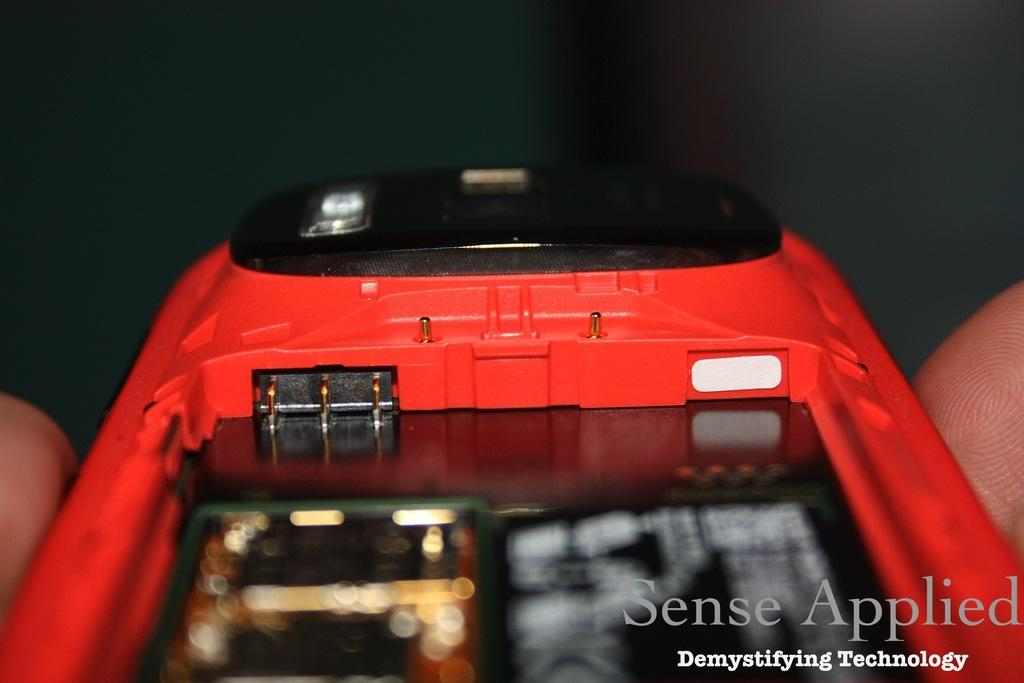<image>
Describe the image concisely. A close up of a red cell phone taken apart by Sense Applied 